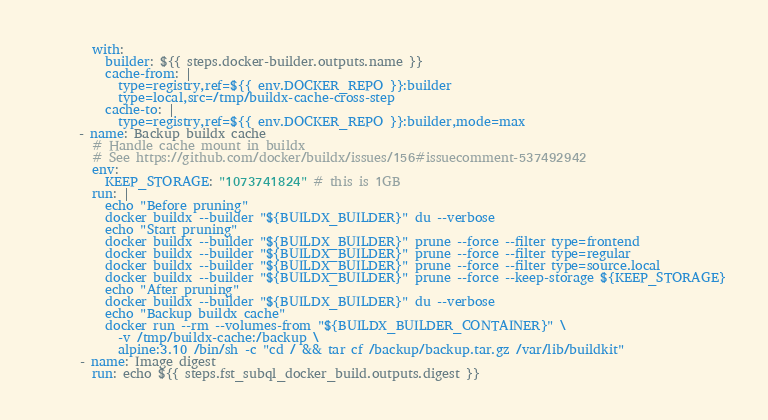Convert code to text. <code><loc_0><loc_0><loc_500><loc_500><_YAML_>        with:
          builder: ${{ steps.docker-builder.outputs.name }}
          cache-from: |
            type=registry,ref=${{ env.DOCKER_REPO }}:builder
            type=local,src=/tmp/buildx-cache-cross-step
          cache-to: |
            type=registry,ref=${{ env.DOCKER_REPO }}:builder,mode=max
      - name: Backup buildx cache
        # Handle cache mount in buildx
        # See https://github.com/docker/buildx/issues/156#issuecomment-537492942
        env:
          KEEP_STORAGE: "1073741824" # this is 1GB
        run: |
          echo "Before pruning"
          docker buildx --builder "${BUILDX_BUILDER}" du --verbose
          echo "Start pruning"
          docker buildx --builder "${BUILDX_BUILDER}" prune --force --filter type=frontend
          docker buildx --builder "${BUILDX_BUILDER}" prune --force --filter type=regular
          docker buildx --builder "${BUILDX_BUILDER}" prune --force --filter type=source.local 
          docker buildx --builder "${BUILDX_BUILDER}" prune --force --keep-storage ${KEEP_STORAGE}
          echo "After pruning"
          docker buildx --builder "${BUILDX_BUILDER}" du --verbose
          echo "Backup buildx cache"
          docker run --rm --volumes-from "${BUILDX_BUILDER_CONTAINER}" \
            -v /tmp/buildx-cache:/backup \
            alpine:3.10 /bin/sh -c "cd / && tar cf /backup/backup.tar.gz /var/lib/buildkit"
      - name: Image digest
        run: echo ${{ steps.fst_subql_docker_build.outputs.digest }}</code> 